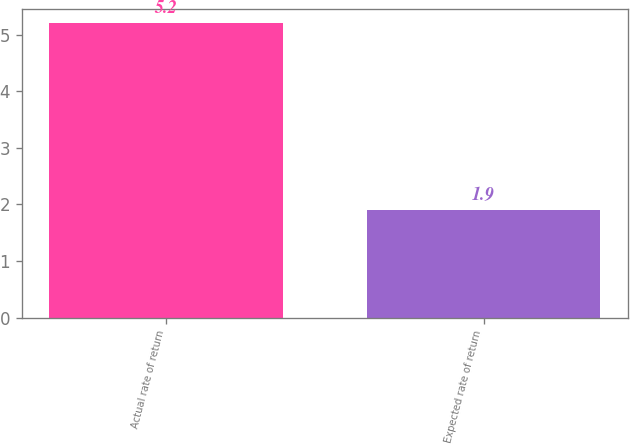Convert chart. <chart><loc_0><loc_0><loc_500><loc_500><bar_chart><fcel>Actual rate of return<fcel>Expected rate of return<nl><fcel>5.2<fcel>1.9<nl></chart> 